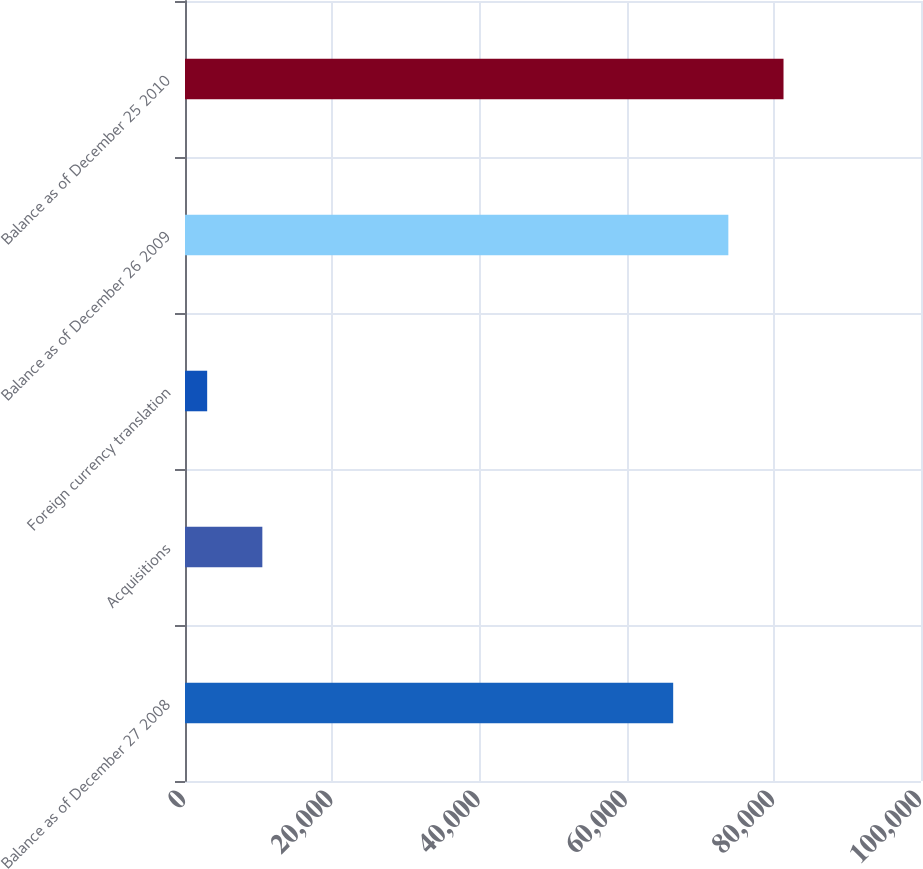<chart> <loc_0><loc_0><loc_500><loc_500><bar_chart><fcel>Balance as of December 27 2008<fcel>Acquisitions<fcel>Foreign currency translation<fcel>Balance as of December 26 2009<fcel>Balance as of December 25 2010<nl><fcel>66329<fcel>10508.6<fcel>3013<fcel>73824.6<fcel>81320.2<nl></chart> 